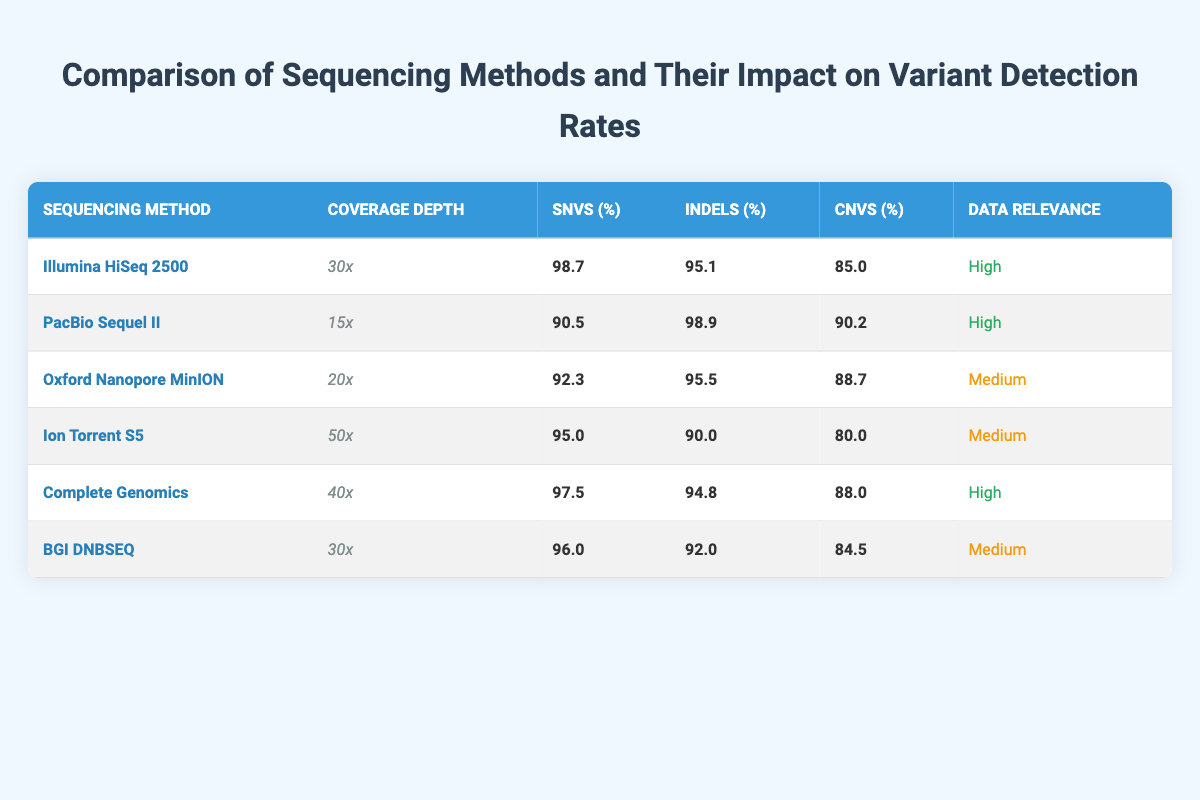What is the variant detection rate for SNVs using the Illumina HiSeq 2500? The table shows that the variant detection rate for SNVs with the Illumina HiSeq 2500 is 98.7%.
Answer: 98.7% Which sequencing method has the highest detection rate for Indels? According to the table, the PacBio Sequel II has the highest detection rate for Indels at 98.9%.
Answer: PacBio Sequel II What is the coverage depth of the Ion Torrent S5? The coverage depth listed in the table for the Ion Torrent S5 is 50x.
Answer: 50x Which method shows a medium level of data relevance? The Oxford Nanopore MinION, Ion Torrent S5, and BGI DNBSEQ methods are all classified as medium relevance according to the table.
Answer: Oxford Nanopore MinION, Ion Torrent S5, BGI DNBSEQ What is the average variant detection rate for CNVs across all methods? The CNV detection rates are 85.0, 90.2, 88.7, 80.0, 88.0, and 84.5. Summing these gives 516.4, and dividing by 6 methods gives an average of 86.07%.
Answer: 86.07% Is it true that the Illumina HiSeq 2500 has a higher SNV detection rate than the Complete Genomics method? Comparing the SNV detection rates from the table, Illumina HiSeq 2500 at 98.7% is higher than Complete Genomics at 97.5%. Therefore, the statement is true.
Answer: Yes Which sequencing methods have a coverage depth of less than 30x? The table indicates that the PacBio Sequel II (15x) and Oxford Nanopore MinION (20x) have a coverage depth of less than 30x.
Answer: PacBio Sequel II, Oxford Nanopore MinION What is the difference in SNV detection rates between the Illumina HiSeq 2500 and BGI DNBSEQ? The SNV detection rate for Illumina HiSeq 2500 is 98.7% and for BGI DNBSEQ is 96.0%. The difference is 98.7% - 96.0% = 2.7%.
Answer: 2.7% Which method has the lowest rate of CNV detection? The Ion Torrent S5 has the lowest CNV detection rate at 80.0%, as per the table data.
Answer: Ion Torrent S5 What is the combined variant detection rate for Indels between Complete Genomics and BGI DNBSEQ? The Indel detection rates are 94.8% for Complete Genomics and 92.0% for BGI DNBSEQ. Adding these gives 94.8 + 92.0 = 186.8%.
Answer: 186.8% 